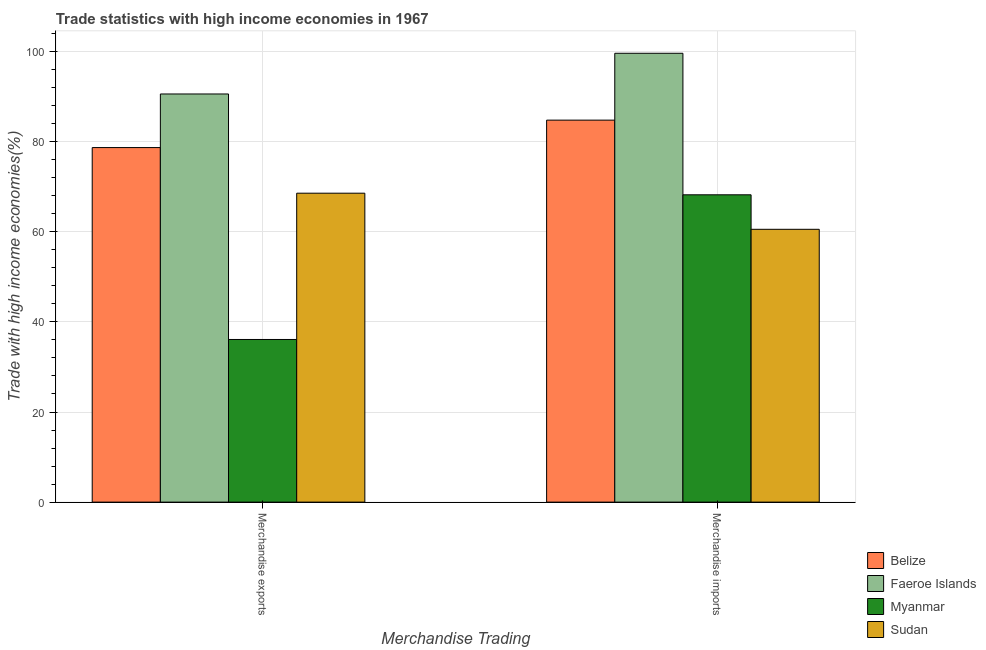How many groups of bars are there?
Ensure brevity in your answer.  2. Are the number of bars per tick equal to the number of legend labels?
Ensure brevity in your answer.  Yes. How many bars are there on the 1st tick from the right?
Your response must be concise. 4. What is the merchandise exports in Sudan?
Make the answer very short. 68.57. Across all countries, what is the maximum merchandise imports?
Your answer should be compact. 99.62. Across all countries, what is the minimum merchandise exports?
Your answer should be compact. 36.1. In which country was the merchandise imports maximum?
Provide a succinct answer. Faeroe Islands. In which country was the merchandise exports minimum?
Make the answer very short. Myanmar. What is the total merchandise imports in the graph?
Give a very brief answer. 313.17. What is the difference between the merchandise imports in Belize and that in Myanmar?
Provide a succinct answer. 16.57. What is the difference between the merchandise imports in Faeroe Islands and the merchandise exports in Belize?
Your answer should be compact. 20.93. What is the average merchandise imports per country?
Provide a short and direct response. 78.29. What is the difference between the merchandise exports and merchandise imports in Faeroe Islands?
Make the answer very short. -9.04. What is the ratio of the merchandise imports in Myanmar to that in Sudan?
Provide a succinct answer. 1.13. What does the 3rd bar from the left in Merchandise exports represents?
Provide a succinct answer. Myanmar. What does the 2nd bar from the right in Merchandise exports represents?
Ensure brevity in your answer.  Myanmar. How many countries are there in the graph?
Ensure brevity in your answer.  4. What is the difference between two consecutive major ticks on the Y-axis?
Your response must be concise. 20. Are the values on the major ticks of Y-axis written in scientific E-notation?
Give a very brief answer. No. Does the graph contain any zero values?
Your answer should be compact. No. Does the graph contain grids?
Give a very brief answer. Yes. How many legend labels are there?
Offer a very short reply. 4. How are the legend labels stacked?
Your answer should be compact. Vertical. What is the title of the graph?
Make the answer very short. Trade statistics with high income economies in 1967. What is the label or title of the X-axis?
Ensure brevity in your answer.  Merchandise Trading. What is the label or title of the Y-axis?
Your answer should be very brief. Trade with high income economies(%). What is the Trade with high income economies(%) of Belize in Merchandise exports?
Offer a very short reply. 78.69. What is the Trade with high income economies(%) in Faeroe Islands in Merchandise exports?
Provide a short and direct response. 90.59. What is the Trade with high income economies(%) of Myanmar in Merchandise exports?
Provide a succinct answer. 36.1. What is the Trade with high income economies(%) of Sudan in Merchandise exports?
Provide a short and direct response. 68.57. What is the Trade with high income economies(%) in Belize in Merchandise imports?
Make the answer very short. 84.78. What is the Trade with high income economies(%) in Faeroe Islands in Merchandise imports?
Your answer should be very brief. 99.62. What is the Trade with high income economies(%) in Myanmar in Merchandise imports?
Provide a short and direct response. 68.21. What is the Trade with high income economies(%) in Sudan in Merchandise imports?
Offer a very short reply. 60.55. Across all Merchandise Trading, what is the maximum Trade with high income economies(%) of Belize?
Keep it short and to the point. 84.78. Across all Merchandise Trading, what is the maximum Trade with high income economies(%) in Faeroe Islands?
Keep it short and to the point. 99.62. Across all Merchandise Trading, what is the maximum Trade with high income economies(%) of Myanmar?
Your answer should be very brief. 68.21. Across all Merchandise Trading, what is the maximum Trade with high income economies(%) of Sudan?
Your answer should be very brief. 68.57. Across all Merchandise Trading, what is the minimum Trade with high income economies(%) of Belize?
Ensure brevity in your answer.  78.69. Across all Merchandise Trading, what is the minimum Trade with high income economies(%) in Faeroe Islands?
Ensure brevity in your answer.  90.59. Across all Merchandise Trading, what is the minimum Trade with high income economies(%) in Myanmar?
Provide a short and direct response. 36.1. Across all Merchandise Trading, what is the minimum Trade with high income economies(%) in Sudan?
Offer a terse response. 60.55. What is the total Trade with high income economies(%) of Belize in the graph?
Your response must be concise. 163.48. What is the total Trade with high income economies(%) in Faeroe Islands in the graph?
Give a very brief answer. 190.21. What is the total Trade with high income economies(%) in Myanmar in the graph?
Ensure brevity in your answer.  104.31. What is the total Trade with high income economies(%) in Sudan in the graph?
Your answer should be very brief. 129.12. What is the difference between the Trade with high income economies(%) in Belize in Merchandise exports and that in Merchandise imports?
Your response must be concise. -6.09. What is the difference between the Trade with high income economies(%) in Faeroe Islands in Merchandise exports and that in Merchandise imports?
Offer a terse response. -9.04. What is the difference between the Trade with high income economies(%) in Myanmar in Merchandise exports and that in Merchandise imports?
Your response must be concise. -32.11. What is the difference between the Trade with high income economies(%) in Sudan in Merchandise exports and that in Merchandise imports?
Make the answer very short. 8.01. What is the difference between the Trade with high income economies(%) in Belize in Merchandise exports and the Trade with high income economies(%) in Faeroe Islands in Merchandise imports?
Make the answer very short. -20.93. What is the difference between the Trade with high income economies(%) in Belize in Merchandise exports and the Trade with high income economies(%) in Myanmar in Merchandise imports?
Make the answer very short. 10.48. What is the difference between the Trade with high income economies(%) in Belize in Merchandise exports and the Trade with high income economies(%) in Sudan in Merchandise imports?
Give a very brief answer. 18.14. What is the difference between the Trade with high income economies(%) of Faeroe Islands in Merchandise exports and the Trade with high income economies(%) of Myanmar in Merchandise imports?
Make the answer very short. 22.38. What is the difference between the Trade with high income economies(%) in Faeroe Islands in Merchandise exports and the Trade with high income economies(%) in Sudan in Merchandise imports?
Offer a very short reply. 30.03. What is the difference between the Trade with high income economies(%) of Myanmar in Merchandise exports and the Trade with high income economies(%) of Sudan in Merchandise imports?
Your answer should be very brief. -24.45. What is the average Trade with high income economies(%) of Belize per Merchandise Trading?
Ensure brevity in your answer.  81.74. What is the average Trade with high income economies(%) of Faeroe Islands per Merchandise Trading?
Your response must be concise. 95.11. What is the average Trade with high income economies(%) in Myanmar per Merchandise Trading?
Provide a short and direct response. 52.16. What is the average Trade with high income economies(%) in Sudan per Merchandise Trading?
Offer a very short reply. 64.56. What is the difference between the Trade with high income economies(%) in Belize and Trade with high income economies(%) in Faeroe Islands in Merchandise exports?
Ensure brevity in your answer.  -11.9. What is the difference between the Trade with high income economies(%) of Belize and Trade with high income economies(%) of Myanmar in Merchandise exports?
Offer a very short reply. 42.59. What is the difference between the Trade with high income economies(%) of Belize and Trade with high income economies(%) of Sudan in Merchandise exports?
Offer a terse response. 10.13. What is the difference between the Trade with high income economies(%) of Faeroe Islands and Trade with high income economies(%) of Myanmar in Merchandise exports?
Your answer should be compact. 54.49. What is the difference between the Trade with high income economies(%) of Faeroe Islands and Trade with high income economies(%) of Sudan in Merchandise exports?
Offer a terse response. 22.02. What is the difference between the Trade with high income economies(%) of Myanmar and Trade with high income economies(%) of Sudan in Merchandise exports?
Provide a short and direct response. -32.47. What is the difference between the Trade with high income economies(%) of Belize and Trade with high income economies(%) of Faeroe Islands in Merchandise imports?
Provide a succinct answer. -14.84. What is the difference between the Trade with high income economies(%) of Belize and Trade with high income economies(%) of Myanmar in Merchandise imports?
Provide a short and direct response. 16.57. What is the difference between the Trade with high income economies(%) of Belize and Trade with high income economies(%) of Sudan in Merchandise imports?
Offer a very short reply. 24.23. What is the difference between the Trade with high income economies(%) in Faeroe Islands and Trade with high income economies(%) in Myanmar in Merchandise imports?
Ensure brevity in your answer.  31.41. What is the difference between the Trade with high income economies(%) of Faeroe Islands and Trade with high income economies(%) of Sudan in Merchandise imports?
Your answer should be compact. 39.07. What is the difference between the Trade with high income economies(%) in Myanmar and Trade with high income economies(%) in Sudan in Merchandise imports?
Your response must be concise. 7.66. What is the ratio of the Trade with high income economies(%) in Belize in Merchandise exports to that in Merchandise imports?
Provide a succinct answer. 0.93. What is the ratio of the Trade with high income economies(%) in Faeroe Islands in Merchandise exports to that in Merchandise imports?
Provide a short and direct response. 0.91. What is the ratio of the Trade with high income economies(%) in Myanmar in Merchandise exports to that in Merchandise imports?
Provide a short and direct response. 0.53. What is the ratio of the Trade with high income economies(%) of Sudan in Merchandise exports to that in Merchandise imports?
Your answer should be very brief. 1.13. What is the difference between the highest and the second highest Trade with high income economies(%) in Belize?
Keep it short and to the point. 6.09. What is the difference between the highest and the second highest Trade with high income economies(%) of Faeroe Islands?
Your answer should be very brief. 9.04. What is the difference between the highest and the second highest Trade with high income economies(%) in Myanmar?
Your answer should be very brief. 32.11. What is the difference between the highest and the second highest Trade with high income economies(%) in Sudan?
Provide a short and direct response. 8.01. What is the difference between the highest and the lowest Trade with high income economies(%) in Belize?
Your answer should be compact. 6.09. What is the difference between the highest and the lowest Trade with high income economies(%) of Faeroe Islands?
Offer a terse response. 9.04. What is the difference between the highest and the lowest Trade with high income economies(%) in Myanmar?
Your answer should be compact. 32.11. What is the difference between the highest and the lowest Trade with high income economies(%) of Sudan?
Keep it short and to the point. 8.01. 